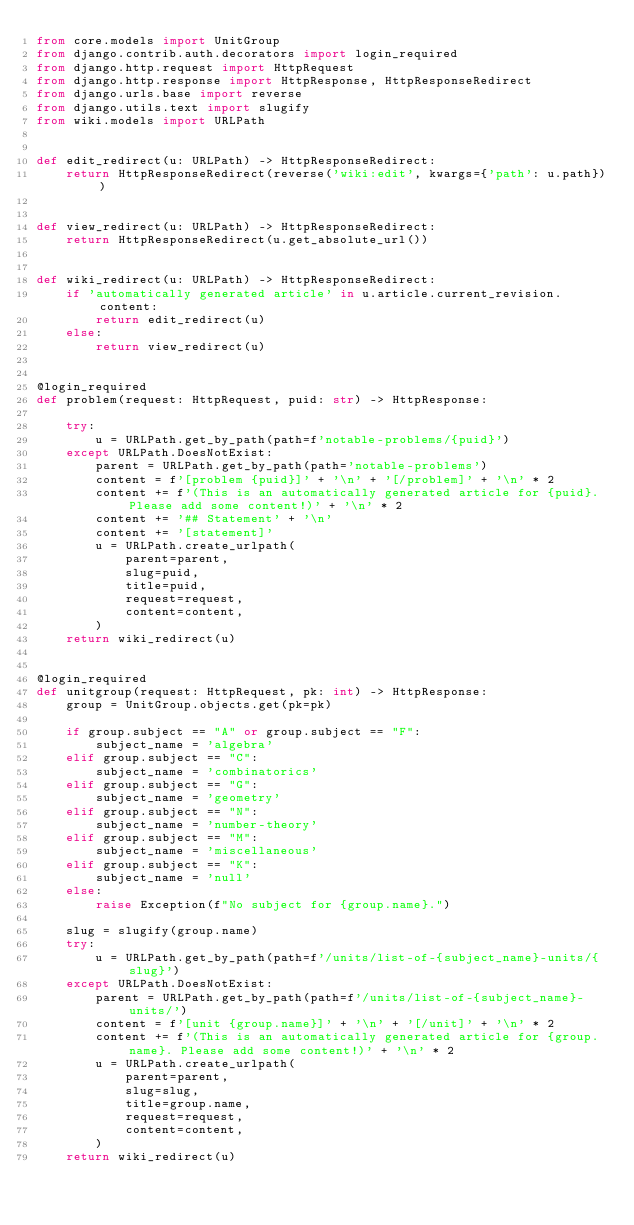<code> <loc_0><loc_0><loc_500><loc_500><_Python_>from core.models import UnitGroup
from django.contrib.auth.decorators import login_required
from django.http.request import HttpRequest
from django.http.response import HttpResponse, HttpResponseRedirect
from django.urls.base import reverse
from django.utils.text import slugify
from wiki.models import URLPath


def edit_redirect(u: URLPath) -> HttpResponseRedirect:
	return HttpResponseRedirect(reverse('wiki:edit', kwargs={'path': u.path}))


def view_redirect(u: URLPath) -> HttpResponseRedirect:
	return HttpResponseRedirect(u.get_absolute_url())


def wiki_redirect(u: URLPath) -> HttpResponseRedirect:
	if 'automatically generated article' in u.article.current_revision.content:
		return edit_redirect(u)
	else:
		return view_redirect(u)


@login_required
def problem(request: HttpRequest, puid: str) -> HttpResponse:

	try:
		u = URLPath.get_by_path(path=f'notable-problems/{puid}')
	except URLPath.DoesNotExist:
		parent = URLPath.get_by_path(path='notable-problems')
		content = f'[problem {puid}]' + '\n' + '[/problem]' + '\n' * 2
		content += f'(This is an automatically generated article for {puid}. Please add some content!)' + '\n' * 2
		content += '## Statement' + '\n'
		content += '[statement]'
		u = URLPath.create_urlpath(
			parent=parent,
			slug=puid,
			title=puid,
			request=request,
			content=content,
		)
	return wiki_redirect(u)


@login_required
def unitgroup(request: HttpRequest, pk: int) -> HttpResponse:
	group = UnitGroup.objects.get(pk=pk)

	if group.subject == "A" or group.subject == "F":
		subject_name = 'algebra'
	elif group.subject == "C":
		subject_name = 'combinatorics'
	elif group.subject == "G":
		subject_name = 'geometry'
	elif group.subject == "N":
		subject_name = 'number-theory'
	elif group.subject == "M":
		subject_name = 'miscellaneous'
	elif group.subject == "K":
		subject_name = 'null'
	else:
		raise Exception(f"No subject for {group.name}.")

	slug = slugify(group.name)
	try:
		u = URLPath.get_by_path(path=f'/units/list-of-{subject_name}-units/{slug}')
	except URLPath.DoesNotExist:
		parent = URLPath.get_by_path(path=f'/units/list-of-{subject_name}-units/')
		content = f'[unit {group.name}]' + '\n' + '[/unit]' + '\n' * 2
		content += f'(This is an automatically generated article for {group.name}. Please add some content!)' + '\n' * 2
		u = URLPath.create_urlpath(
			parent=parent,
			slug=slug,
			title=group.name,
			request=request,
			content=content,
		)
	return wiki_redirect(u)
</code> 